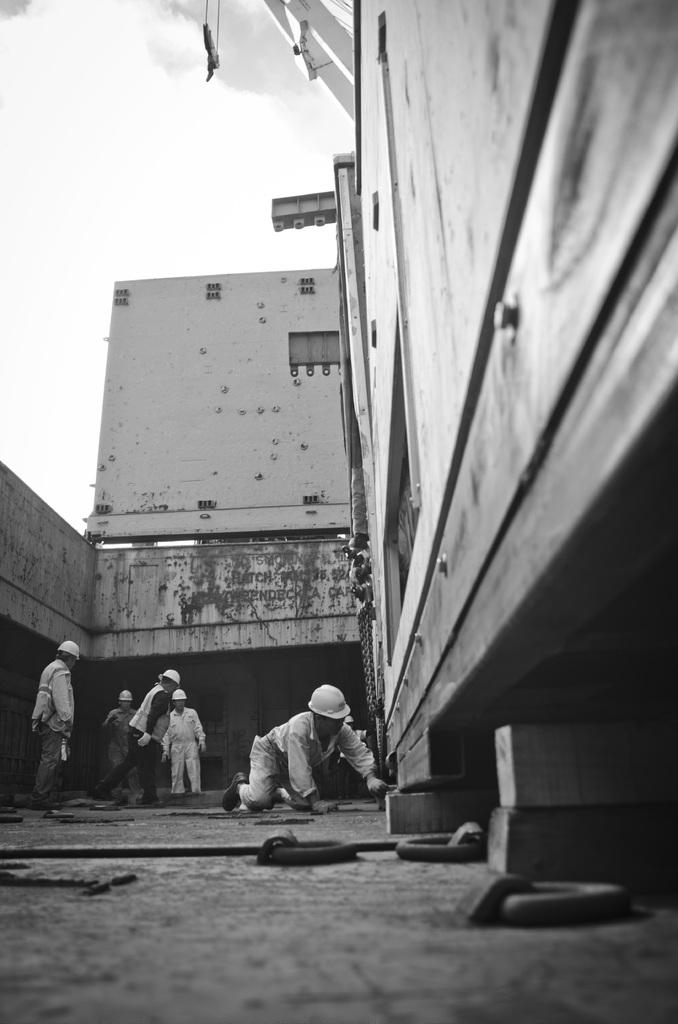What is the color scheme of the image? The image is black and white. Who or what can be seen in the image? There are persons and buildings in the image. What is visible in the background of the image? The sky is visible in the background of the image. What level of difficulty is the school in the image designed for? There is no school present in the image, so it is not possible to determine the level of difficulty it is designed for. 